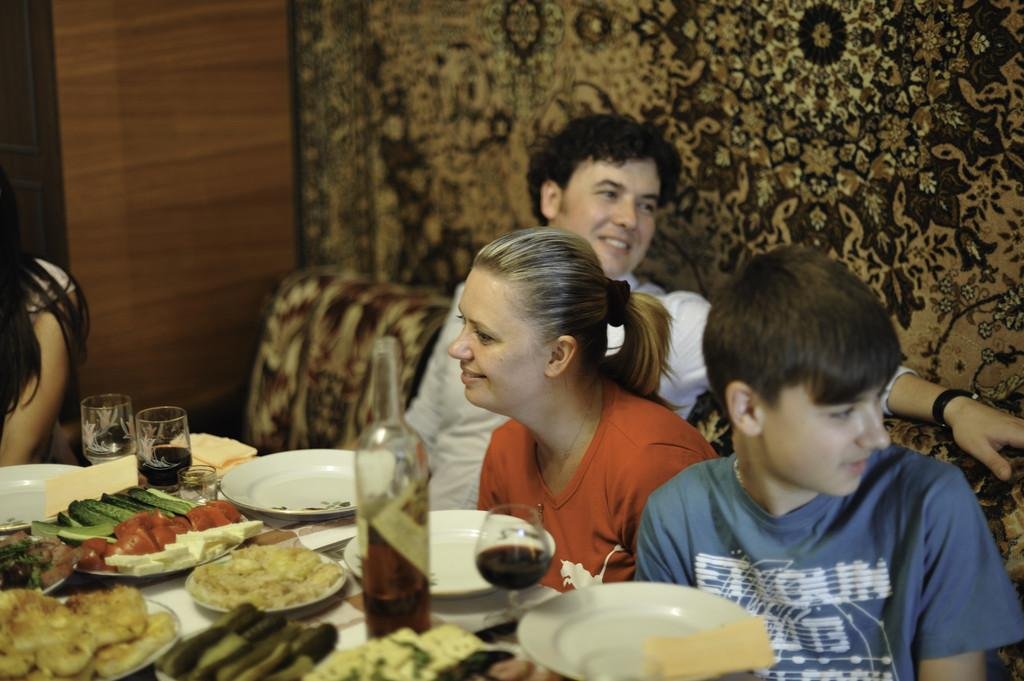Who or what is present in the image? There are people in the image. What can be observed about the people's expressions? Some people in the image have smiles on their faces. What piece of furniture is visible in the image? There is a table in the image. What items are on the table? There is food and glasses on the table. What type of wax is being used to create the people's smiles in the image? There is no wax present in the image, and the people's smiles are not created using wax. Can you tell me how many aunts are in the image? There is no information about aunts in the image, so it cannot be determined how many are present. 